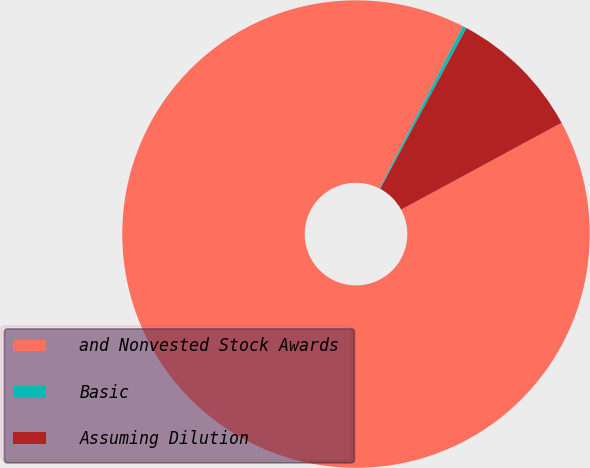Convert chart. <chart><loc_0><loc_0><loc_500><loc_500><pie_chart><fcel>and Nonvested Stock Awards<fcel>Basic<fcel>Assuming Dilution<nl><fcel>90.45%<fcel>0.27%<fcel>9.28%<nl></chart> 